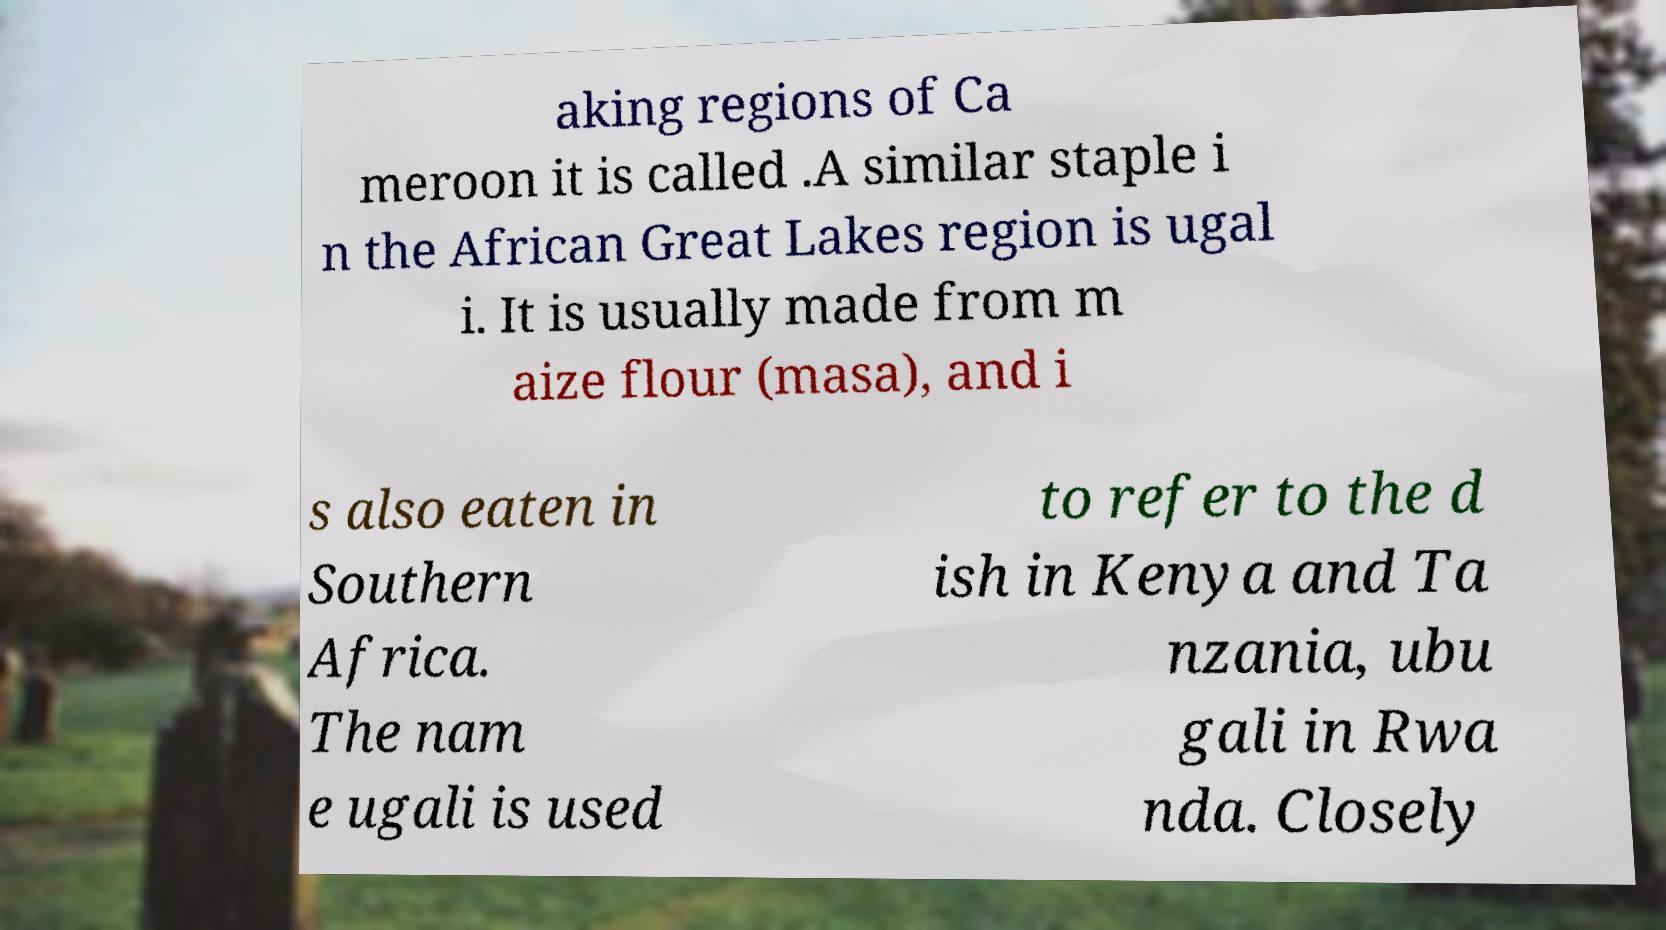Please read and relay the text visible in this image. What does it say? aking regions of Ca meroon it is called .A similar staple i n the African Great Lakes region is ugal i. It is usually made from m aize flour (masa), and i s also eaten in Southern Africa. The nam e ugali is used to refer to the d ish in Kenya and Ta nzania, ubu gali in Rwa nda. Closely 